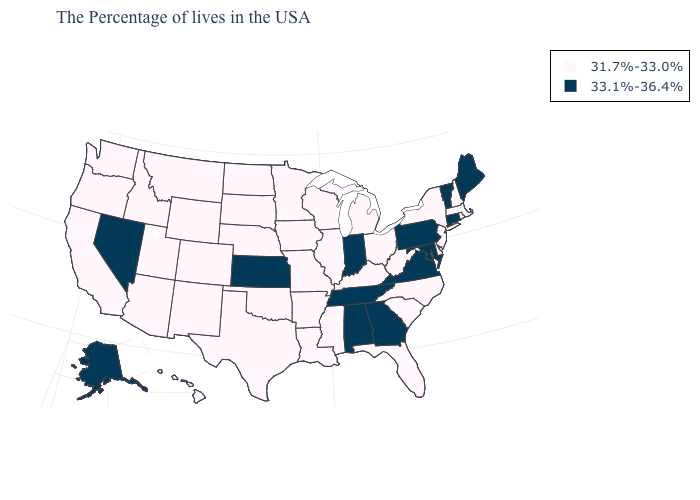What is the value of New Mexico?
Short answer required. 31.7%-33.0%. Among the states that border Utah , does Nevada have the highest value?
Write a very short answer. Yes. What is the value of Colorado?
Short answer required. 31.7%-33.0%. Name the states that have a value in the range 31.7%-33.0%?
Quick response, please. Massachusetts, Rhode Island, New Hampshire, New York, New Jersey, Delaware, North Carolina, South Carolina, West Virginia, Ohio, Florida, Michigan, Kentucky, Wisconsin, Illinois, Mississippi, Louisiana, Missouri, Arkansas, Minnesota, Iowa, Nebraska, Oklahoma, Texas, South Dakota, North Dakota, Wyoming, Colorado, New Mexico, Utah, Montana, Arizona, Idaho, California, Washington, Oregon, Hawaii. What is the highest value in the West ?
Concise answer only. 33.1%-36.4%. Name the states that have a value in the range 31.7%-33.0%?
Be succinct. Massachusetts, Rhode Island, New Hampshire, New York, New Jersey, Delaware, North Carolina, South Carolina, West Virginia, Ohio, Florida, Michigan, Kentucky, Wisconsin, Illinois, Mississippi, Louisiana, Missouri, Arkansas, Minnesota, Iowa, Nebraska, Oklahoma, Texas, South Dakota, North Dakota, Wyoming, Colorado, New Mexico, Utah, Montana, Arizona, Idaho, California, Washington, Oregon, Hawaii. What is the value of Wisconsin?
Write a very short answer. 31.7%-33.0%. Name the states that have a value in the range 31.7%-33.0%?
Keep it brief. Massachusetts, Rhode Island, New Hampshire, New York, New Jersey, Delaware, North Carolina, South Carolina, West Virginia, Ohio, Florida, Michigan, Kentucky, Wisconsin, Illinois, Mississippi, Louisiana, Missouri, Arkansas, Minnesota, Iowa, Nebraska, Oklahoma, Texas, South Dakota, North Dakota, Wyoming, Colorado, New Mexico, Utah, Montana, Arizona, Idaho, California, Washington, Oregon, Hawaii. Name the states that have a value in the range 33.1%-36.4%?
Concise answer only. Maine, Vermont, Connecticut, Maryland, Pennsylvania, Virginia, Georgia, Indiana, Alabama, Tennessee, Kansas, Nevada, Alaska. Among the states that border South Dakota , which have the highest value?
Short answer required. Minnesota, Iowa, Nebraska, North Dakota, Wyoming, Montana. What is the highest value in the MidWest ?
Write a very short answer. 33.1%-36.4%. Does Missouri have the same value as Minnesota?
Short answer required. Yes. Which states have the highest value in the USA?
Write a very short answer. Maine, Vermont, Connecticut, Maryland, Pennsylvania, Virginia, Georgia, Indiana, Alabama, Tennessee, Kansas, Nevada, Alaska. What is the value of Alaska?
Be succinct. 33.1%-36.4%. What is the highest value in the USA?
Answer briefly. 33.1%-36.4%. 